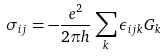<formula> <loc_0><loc_0><loc_500><loc_500>\sigma _ { i j } = - \frac { e ^ { 2 } } { 2 \pi h } \sum _ { k } \epsilon _ { i j k } G _ { k }</formula> 